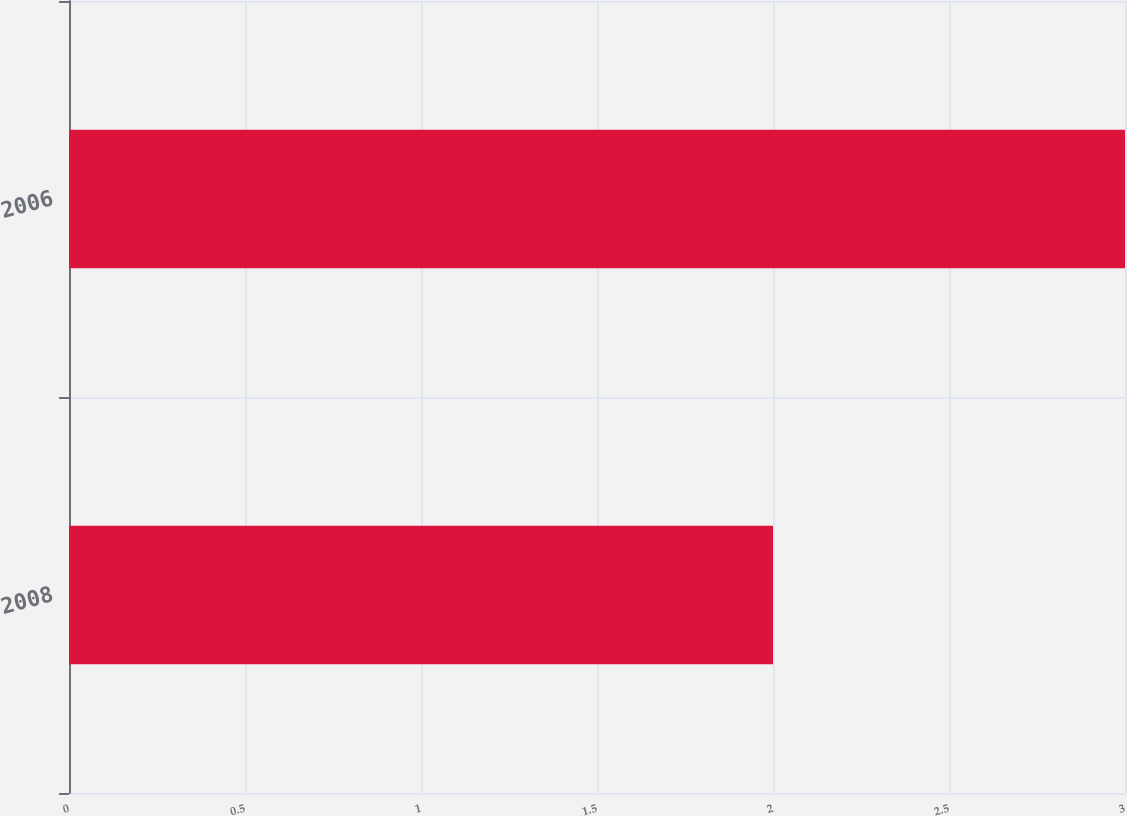Convert chart to OTSL. <chart><loc_0><loc_0><loc_500><loc_500><bar_chart><fcel>2008<fcel>2006<nl><fcel>2<fcel>3<nl></chart> 